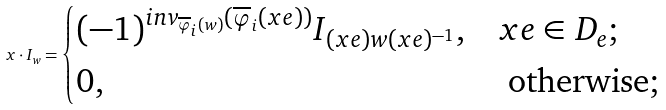<formula> <loc_0><loc_0><loc_500><loc_500>x \cdot I _ { w } = \begin{cases} ( - 1 ) ^ { i n v _ { \overline { \varphi } _ { i } ( w ) } ( \overline { \varphi } _ { i } ( x e ) ) } I _ { ( x e ) w ( x e ) ^ { - 1 } } , & x e \in D _ { e } ; \\ 0 , & \text { otherwise;} \end{cases}</formula> 